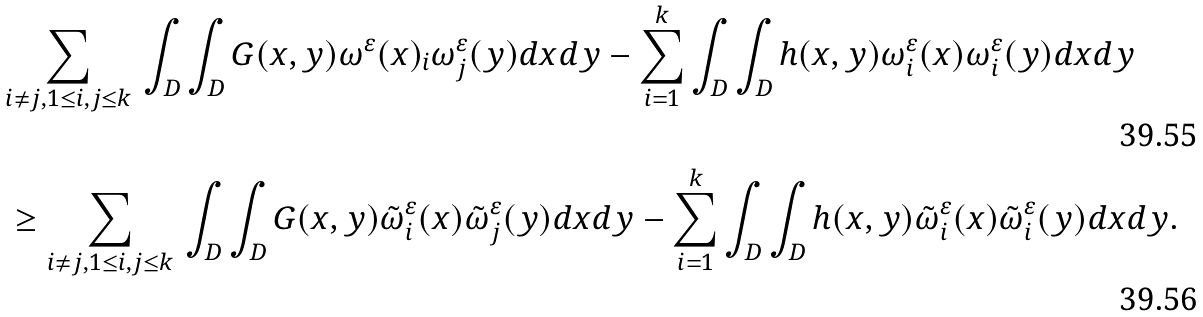<formula> <loc_0><loc_0><loc_500><loc_500>& \sum _ { { i \not = j } , { 1 \leq i , j \leq k } } \, \int _ { D } \int _ { D } G ( x , y ) \omega ^ { \varepsilon } ( x ) _ { i } \omega ^ { \varepsilon } _ { j } ( y ) d x d y - \sum _ { i = 1 } ^ { k } \int _ { D } \int _ { D } h ( x , y ) \omega ^ { \varepsilon } _ { i } ( x ) \omega ^ { \varepsilon } _ { i } ( y ) d x d y \\ & \, \geq \sum _ { { i \not = j } , { 1 \leq i , j \leq k } } \, \int _ { D } \int _ { D } G ( x , y ) \tilde { \omega } ^ { \varepsilon } _ { i } ( x ) \tilde { \omega } ^ { \varepsilon } _ { j } ( y ) d x d y - \sum _ { i = 1 } ^ { k } \int _ { D } \int _ { D } h ( x , y ) \tilde { \omega } ^ { \varepsilon } _ { i } ( x ) \tilde { \omega } ^ { \varepsilon } _ { i } ( y ) d x d y .</formula> 